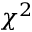Convert formula to latex. <formula><loc_0><loc_0><loc_500><loc_500>\chi ^ { 2 }</formula> 